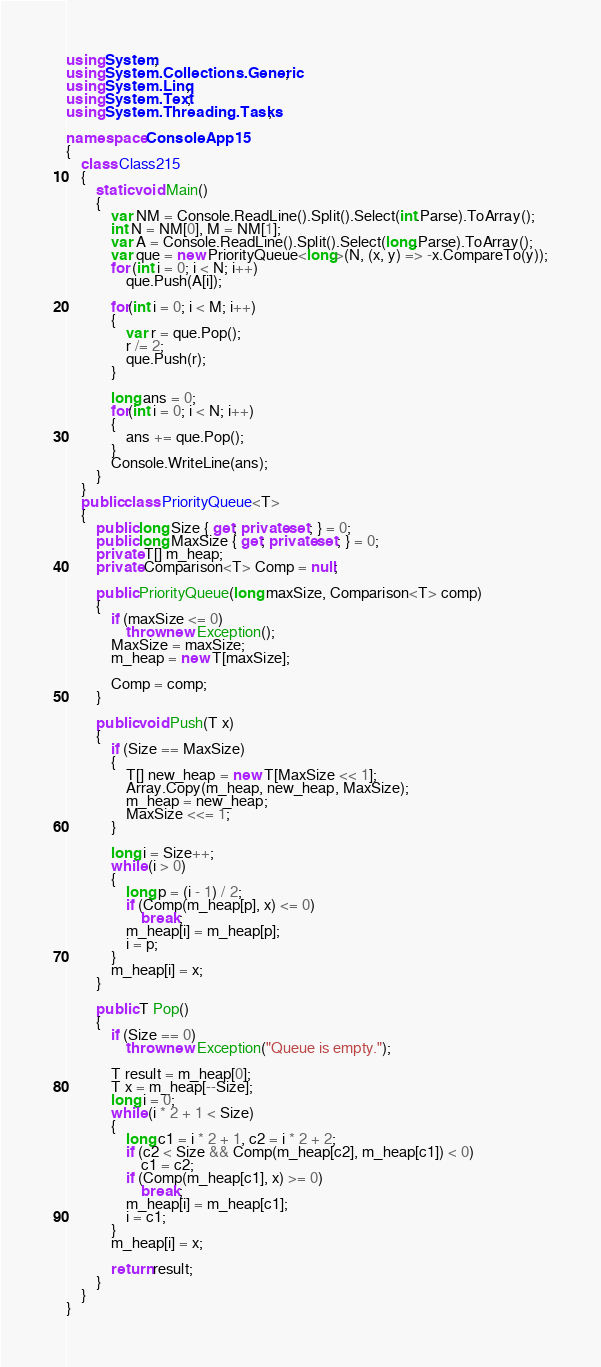Convert code to text. <code><loc_0><loc_0><loc_500><loc_500><_C#_>using System;
using System.Collections.Generic;
using System.Linq;
using System.Text;
using System.Threading.Tasks;

namespace ConsoleApp15
{
    class Class215
    {
        static void Main()
        {
            var NM = Console.ReadLine().Split().Select(int.Parse).ToArray();
            int N = NM[0], M = NM[1];
            var A = Console.ReadLine().Split().Select(long.Parse).ToArray();
            var que = new PriorityQueue<long>(N, (x, y) => -x.CompareTo(y));
            for (int i = 0; i < N; i++)
                que.Push(A[i]);

            for(int i = 0; i < M; i++)
            {
                var r = que.Pop();
                r /= 2;
                que.Push(r);
            }

            long ans = 0;
            for(int i = 0; i < N; i++)
            {
                ans += que.Pop();
            }
            Console.WriteLine(ans);
        }
    }
    public class PriorityQueue<T>
    {
        public long Size { get; private set; } = 0;
        public long MaxSize { get; private set; } = 0;
        private T[] m_heap;
        private Comparison<T> Comp = null;

        public PriorityQueue(long maxSize, Comparison<T> comp)
        {
            if (maxSize <= 0)
                throw new Exception();
            MaxSize = maxSize;
            m_heap = new T[maxSize];

            Comp = comp;
        }

        public void Push(T x)
        {
            if (Size == MaxSize)
            {
                T[] new_heap = new T[MaxSize << 1];
                Array.Copy(m_heap, new_heap, MaxSize);
                m_heap = new_heap;
                MaxSize <<= 1;
            }

            long i = Size++;
            while (i > 0)
            {
                long p = (i - 1) / 2;
                if (Comp(m_heap[p], x) <= 0)
                    break;
                m_heap[i] = m_heap[p];
                i = p;
            }
            m_heap[i] = x;
        }

        public T Pop()
        {
            if (Size == 0)
                throw new Exception("Queue is empty.");

            T result = m_heap[0];
            T x = m_heap[--Size];
            long i = 0;
            while (i * 2 + 1 < Size)
            {
                long c1 = i * 2 + 1, c2 = i * 2 + 2;
                if (c2 < Size && Comp(m_heap[c2], m_heap[c1]) < 0)
                    c1 = c2;
                if (Comp(m_heap[c1], x) >= 0)
                    break;
                m_heap[i] = m_heap[c1];
                i = c1;
            }
            m_heap[i] = x;

            return result;
        }
    }
}
</code> 